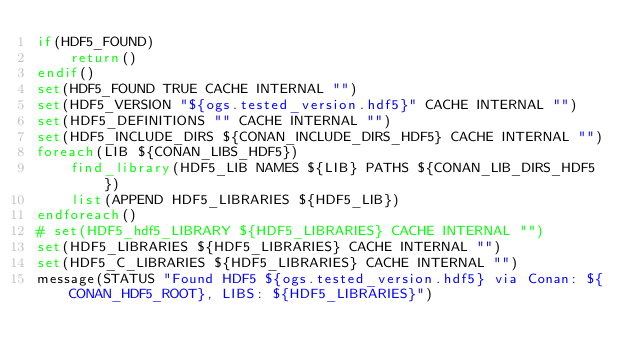Convert code to text. <code><loc_0><loc_0><loc_500><loc_500><_CMake_>if(HDF5_FOUND)
    return()
endif()
set(HDF5_FOUND TRUE CACHE INTERNAL "")
set(HDF5_VERSION "${ogs.tested_version.hdf5}" CACHE INTERNAL "")
set(HDF5_DEFINITIONS "" CACHE INTERNAL "")
set(HDF5_INCLUDE_DIRS ${CONAN_INCLUDE_DIRS_HDF5} CACHE INTERNAL "")
foreach(LIB ${CONAN_LIBS_HDF5})
    find_library(HDF5_LIB NAMES ${LIB} PATHS ${CONAN_LIB_DIRS_HDF5})
    list(APPEND HDF5_LIBRARIES ${HDF5_LIB})
endforeach()
# set(HDF5_hdf5_LIBRARY ${HDF5_LIBRARIES} CACHE INTERNAL "")
set(HDF5_LIBRARIES ${HDF5_LIBRARIES} CACHE INTERNAL "")
set(HDF5_C_LIBRARIES ${HDF5_LIBRARIES} CACHE INTERNAL "")
message(STATUS "Found HDF5 ${ogs.tested_version.hdf5} via Conan: ${CONAN_HDF5_ROOT}, LIBS: ${HDF5_LIBRARIES}")</code> 